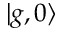<formula> <loc_0><loc_0><loc_500><loc_500>| g , 0 \rangle</formula> 